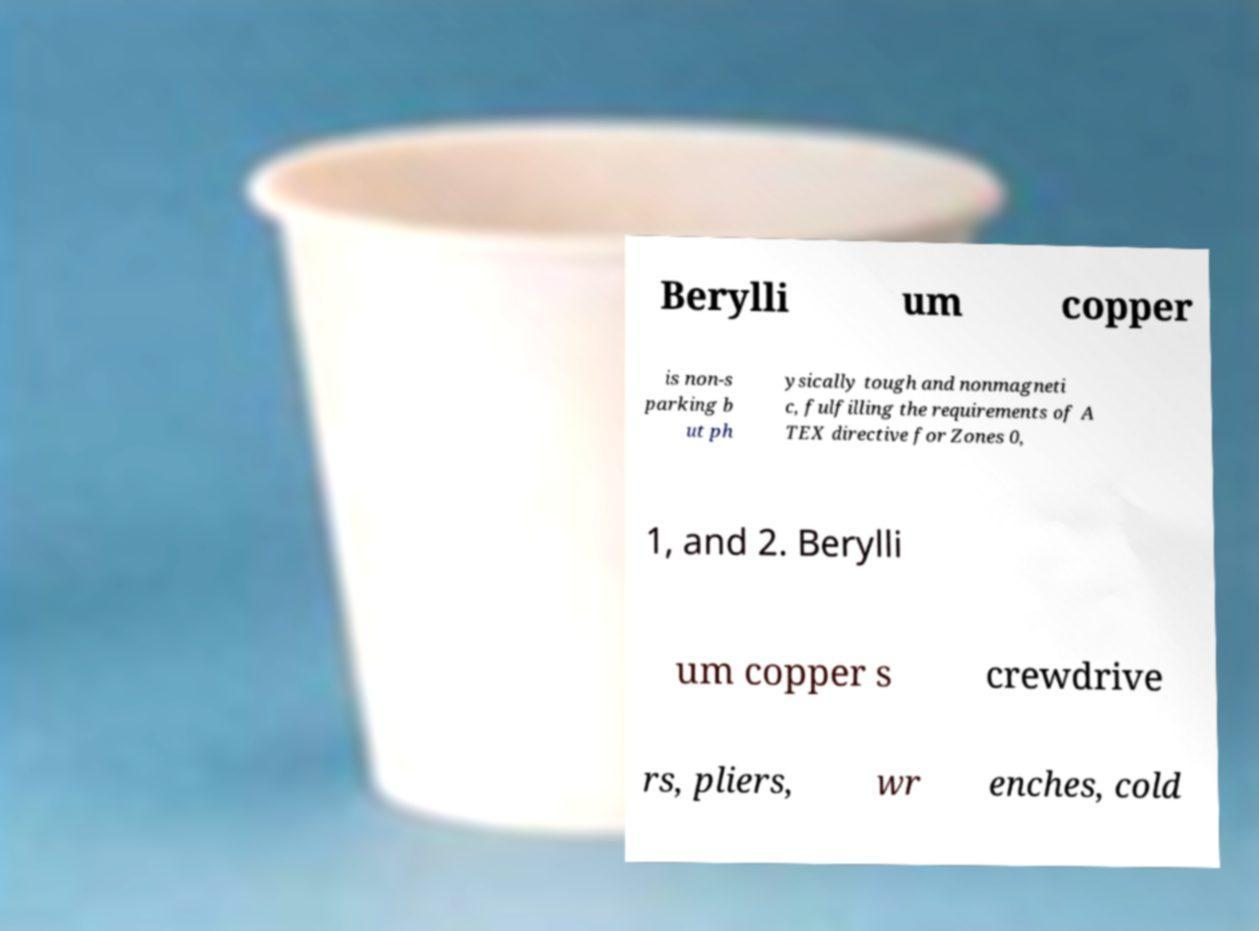Please identify and transcribe the text found in this image. Berylli um copper is non-s parking b ut ph ysically tough and nonmagneti c, fulfilling the requirements of A TEX directive for Zones 0, 1, and 2. Berylli um copper s crewdrive rs, pliers, wr enches, cold 